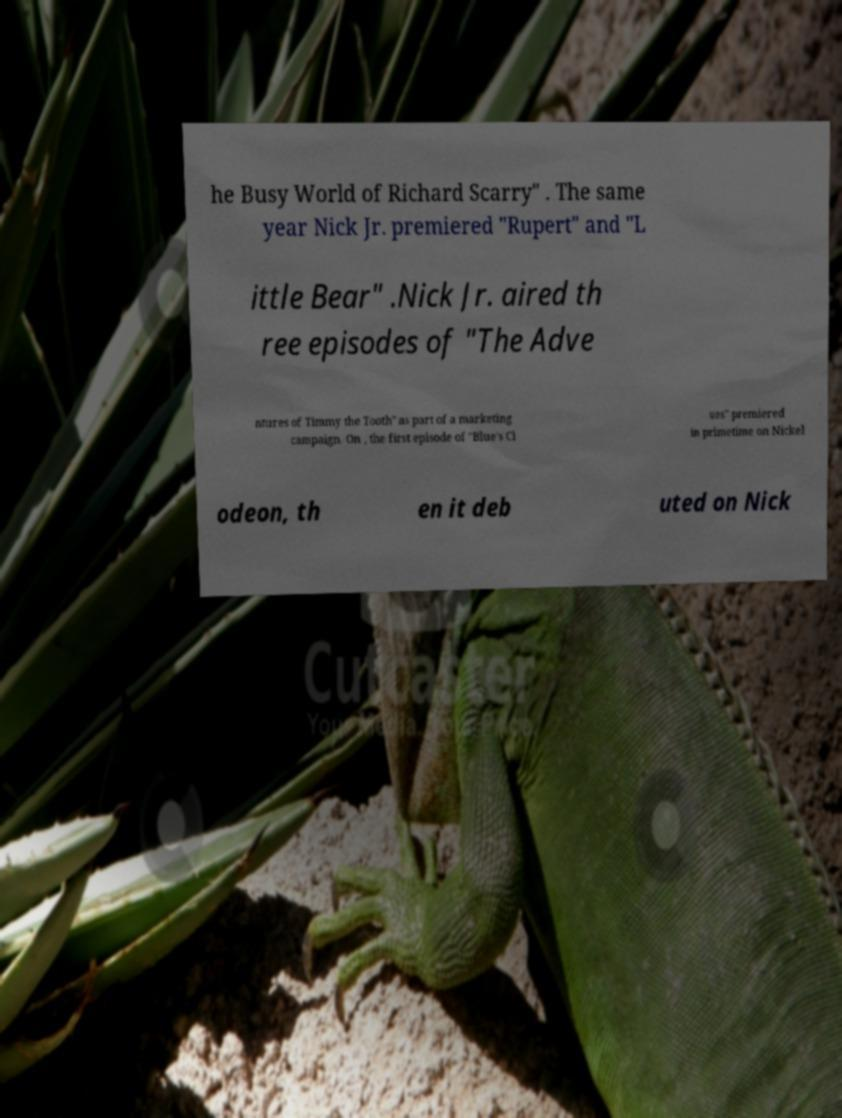Could you assist in decoding the text presented in this image and type it out clearly? he Busy World of Richard Scarry" . The same year Nick Jr. premiered "Rupert" and "L ittle Bear" .Nick Jr. aired th ree episodes of "The Adve ntures of Timmy the Tooth" as part of a marketing campaign. On , the first episode of "Blue's Cl ues" premiered in primetime on Nickel odeon, th en it deb uted on Nick 